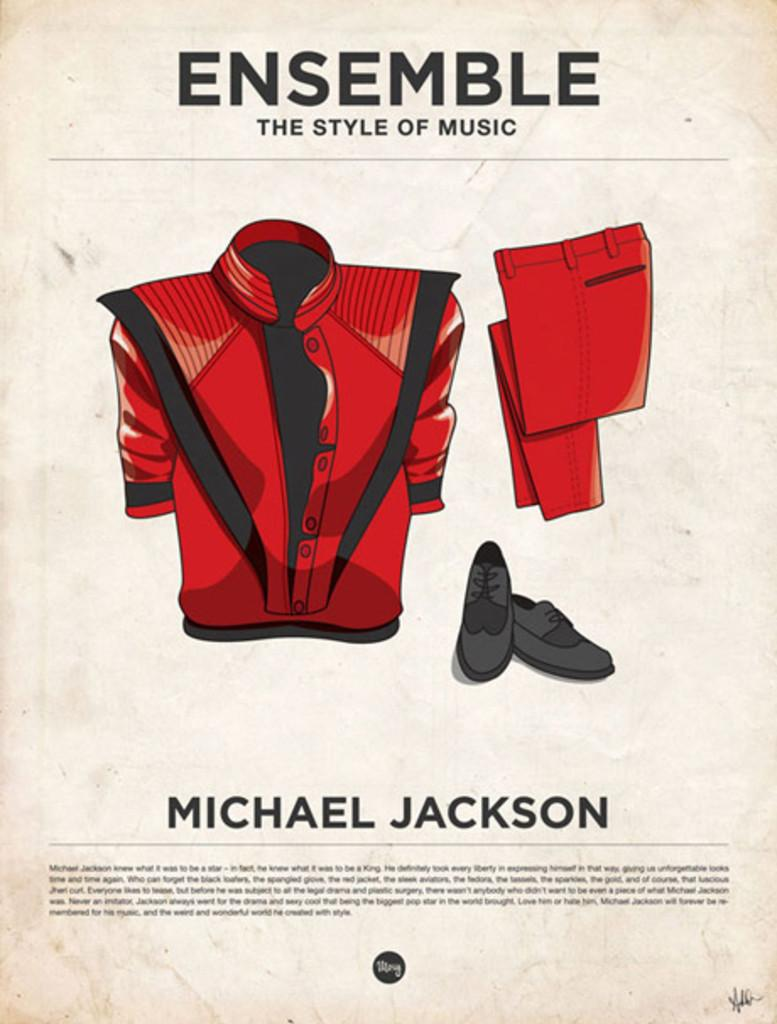<image>
Give a short and clear explanation of the subsequent image. a poster of Michal Jackson's Ensemble the style of music 